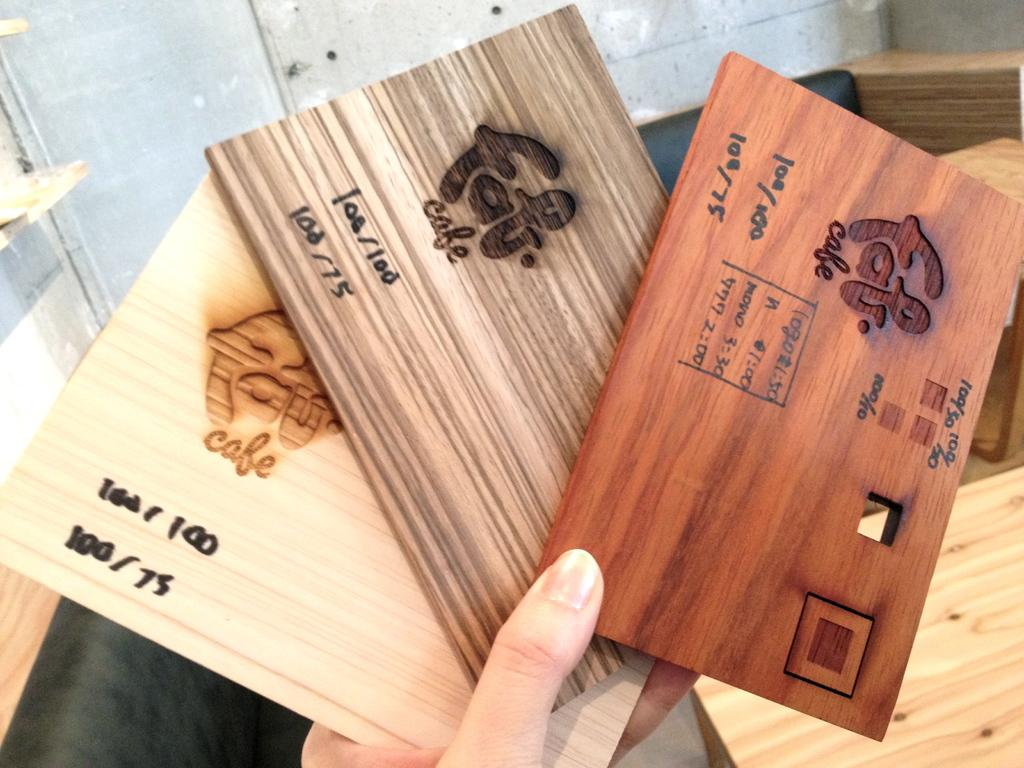Who or what is present in the image? There is a person in the image. What is the person holding in the image? The person is holding three wooden cards. What information is on the wooden cards? The wooden cards have a cafe name on them, as well as other details. What type of tank can be seen in the image? There is no tank present in the image. How many clams are visible on the wooden cards? There are no clams mentioned or depicted on the wooden cards in the image. 